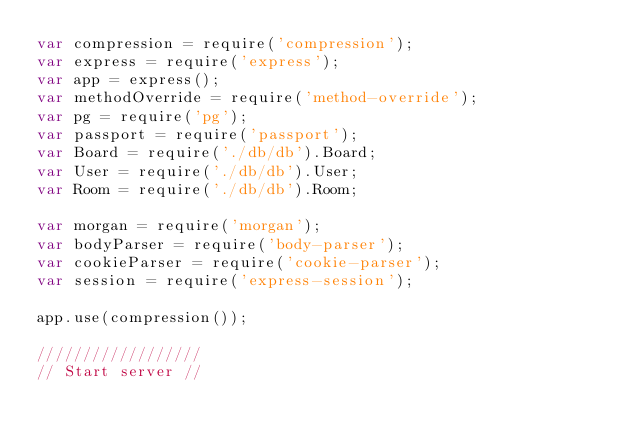Convert code to text. <code><loc_0><loc_0><loc_500><loc_500><_JavaScript_>var compression = require('compression');
var express = require('express');
var app = express();
var methodOverride = require('method-override');
var pg = require('pg');
var passport = require('passport');
var Board = require('./db/db').Board;
var User = require('./db/db').User;
var Room = require('./db/db').Room;

var morgan = require('morgan');
var bodyParser = require('body-parser');
var cookieParser = require('cookie-parser');
var session = require('express-session');

app.use(compression());

//////////////////
// Start server //</code> 